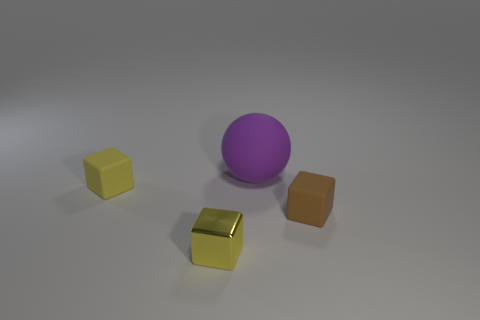Subtract all brown cubes. Subtract all brown cylinders. How many cubes are left? 2 Add 4 small cyan metallic cylinders. How many objects exist? 8 Subtract all balls. How many objects are left? 3 Subtract 0 cyan cubes. How many objects are left? 4 Subtract all purple things. Subtract all big purple balls. How many objects are left? 2 Add 2 matte objects. How many matte objects are left? 5 Add 1 yellow metallic blocks. How many yellow metallic blocks exist? 2 